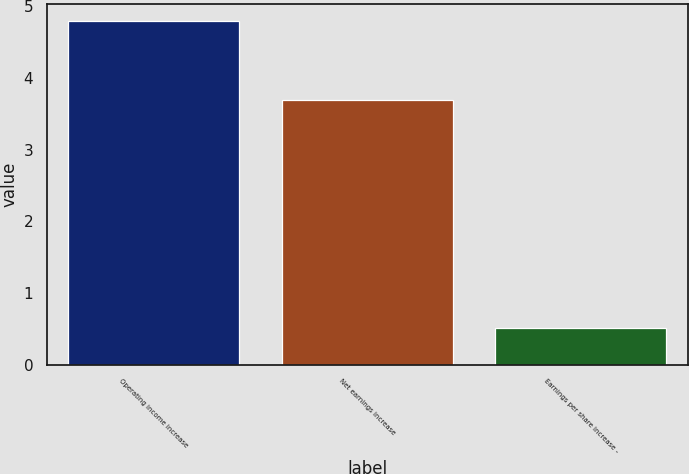Convert chart. <chart><loc_0><loc_0><loc_500><loc_500><bar_chart><fcel>Operating income increase<fcel>Net earnings increase<fcel>Earnings per share increase -<nl><fcel>4.8<fcel>3.7<fcel>0.51<nl></chart> 